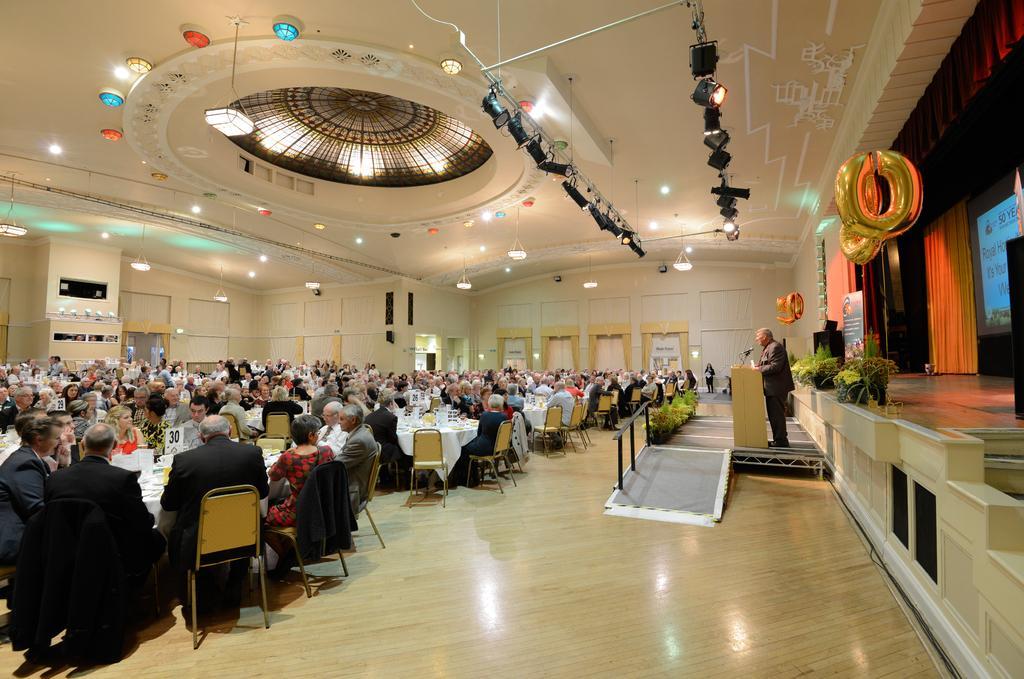Describe this image in one or two sentences. In this image I can see group of people sitting on the chairs. We can see some objects on the table. In front I can see person standing in front of the podium. I can see stage,screen,curtain and balloons. Top I can see lights and wall. 